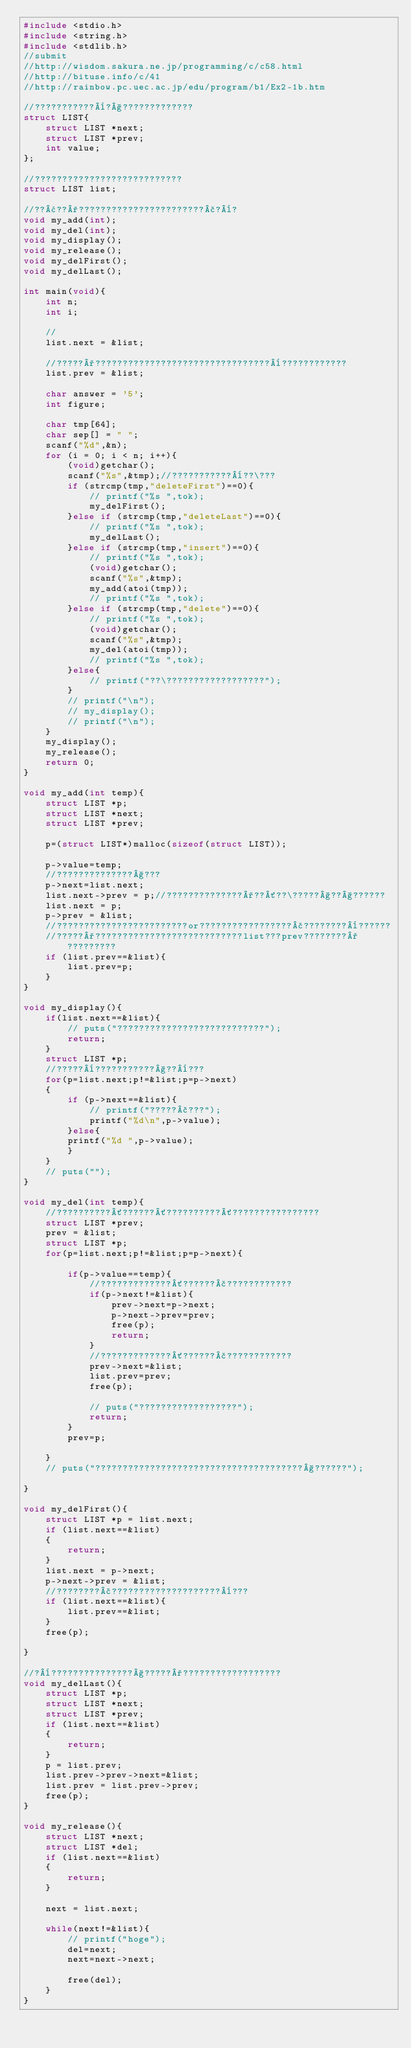<code> <loc_0><loc_0><loc_500><loc_500><_C_>#include <stdio.h>
#include <string.h>
#include <stdlib.h>
//submit
//http://wisdom.sakura.ne.jp/programming/c/c58.html
//http://bituse.info/c/41
//http://rainbow.pc.uec.ac.jp/edu/program/b1/Ex2-1b.htm

//???????????¨?§?????????????
struct LIST{
    struct LIST *next;
    struct LIST *prev;
    int value;
};

//???????????????????????????
struct LIST list;

//??¢??°???????????????????????£?¨?
void my_add(int);
void my_del(int);
void my_display();
void my_release();
void my_delFirst();
void my_delLast();

int main(void){
    int n;
    int i;

    //
    list.next = &list;

    //?????°????????????????????????????????¨????????????
    list.prev = &list;

    char answer = '5';
    int figure;

    char tmp[64];
    char sep[] = " ";
    scanf("%d",&n);
    for (i = 0; i < n; i++){
        (void)getchar();
        scanf("%s",&tmp);//???????????¨??\???
        if (strcmp(tmp,"deleteFirst")==0){
            // printf("%s ",tok);
            my_delFirst();
        }else if (strcmp(tmp,"deleteLast")==0){
            // printf("%s ",tok);
            my_delLast();
        }else if (strcmp(tmp,"insert")==0){
            // printf("%s ",tok);
            (void)getchar();
            scanf("%s",&tmp);
            my_add(atoi(tmp));
            // printf("%s ",tok);
        }else if (strcmp(tmp,"delete")==0){
            // printf("%s ",tok);
            (void)getchar();
            scanf("%s",&tmp);
            my_del(atoi(tmp));
            // printf("%s ",tok);
        }else{
            // printf("??\??????????????????");
        }
        // printf("\n");
        // my_display();
        // printf("\n");
    }
    my_display();
    my_release();
    return 0;
}

void my_add(int temp){
    struct LIST *p;
    struct LIST *next;
    struct LIST *prev;

    p=(struct LIST*)malloc(sizeof(struct LIST));

    p->value=temp;
    //??????????????§???
    p->next=list.next;
    list.next->prev = p;//??????????????°??´??\?????§??§??????
    list.next = p;
    p->prev = &list;
    //????????????????????????or?????????????????£????????¨??????
    //?????°???????????????????????????list???prev????????°?????????
    if (list.prev==&list){
        list.prev=p;
    }
}

void my_display(){
    if(list.next==&list){
        // puts("???????????????????????????");
        return;
    }
    struct LIST *p;
    //?????¨???????????§??¨???
    for(p=list.next;p!=&list;p=p->next)
    {
        if (p->next==&list){
            // printf("?????£???");
            printf("%d\n",p->value);
        }else{
        printf("%d ",p->value);
        }
    }
    // puts("");
}

void my_del(int temp){
    //??????????´??????´??????????´????????????????
    struct LIST *prev;
    prev = &list;
    struct LIST *p;
    for(p=list.next;p!=&list;p=p->next){

        if(p->value==temp){
            //?????????????´??????£????????????
            if(p->next!=&list){
                prev->next=p->next;
                p->next->prev=prev;
                free(p);
                return;
            }
            //?????????????´??????£????????????
            prev->next=&list;
            list.prev=prev;
            free(p);

            // puts("??????????????????");
            return;
        }
        prev=p;

    }
    // puts("??????????????????????????????????????§??????");

}

void my_delFirst(){
    struct LIST *p = list.next;
    if (list.next==&list)
    {
        return;
    }
    list.next = p->next;
    p->next->prev = &list;
    //????????£????????????????????¨???
    if (list.next==&list){
        list.prev==&list;
    }
    free(p);

}

//?¨???????????????§?????°??????????????????
void my_delLast(){
    struct LIST *p;
    struct LIST *next;
    struct LIST *prev;
    if (list.next==&list)
    {
        return;
    }
    p = list.prev;
    list.prev->prev->next=&list;
    list.prev = list.prev->prev;
    free(p);
}

void my_release(){
    struct LIST *next;
    struct LIST *del;
    if (list.next==&list)
    {
        return;
    }

    next = list.next;

    while(next!=&list){
        // printf("hoge");
        del=next;
        next=next->next;

        free(del);
    }
}</code> 